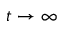Convert formula to latex. <formula><loc_0><loc_0><loc_500><loc_500>t \rightarrow \infty</formula> 